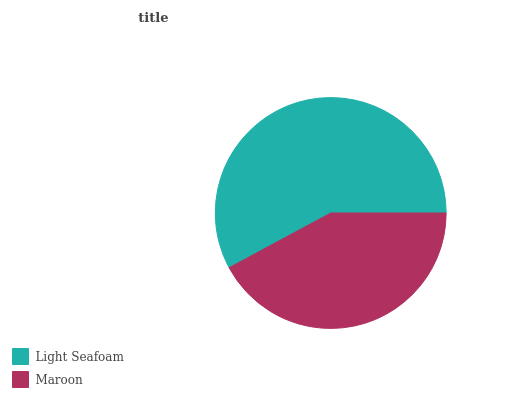Is Maroon the minimum?
Answer yes or no. Yes. Is Light Seafoam the maximum?
Answer yes or no. Yes. Is Maroon the maximum?
Answer yes or no. No. Is Light Seafoam greater than Maroon?
Answer yes or no. Yes. Is Maroon less than Light Seafoam?
Answer yes or no. Yes. Is Maroon greater than Light Seafoam?
Answer yes or no. No. Is Light Seafoam less than Maroon?
Answer yes or no. No. Is Light Seafoam the high median?
Answer yes or no. Yes. Is Maroon the low median?
Answer yes or no. Yes. Is Maroon the high median?
Answer yes or no. No. Is Light Seafoam the low median?
Answer yes or no. No. 